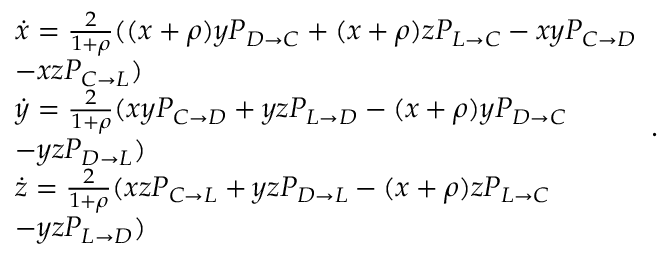Convert formula to latex. <formula><loc_0><loc_0><loc_500><loc_500>\begin{array} { l } { \dot { x } = \frac { 2 } { 1 + \rho } ( ( x + \rho ) y P _ { D \to C } + ( x + \rho ) z P _ { L \to C } - x y P _ { C \to D } } \\ { - x z P _ { C \to L } ) } \\ { \dot { y } = \frac { 2 } { 1 + \rho } ( x y P _ { C \to D } + y z P _ { L \to D } - ( x + \rho ) y P _ { D \to C } } \\ { - y z P _ { D \to L } ) } \\ { \dot { z } = \frac { 2 } { 1 + \rho } ( x z P _ { C \to L } + y z P _ { D \to L } - ( x + \rho ) z P _ { L \to C } } \\ { - y z P _ { L \to D } ) } \end{array} .</formula> 